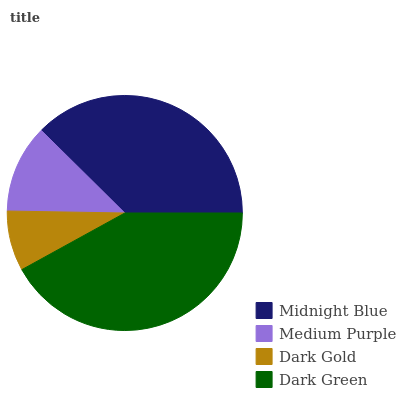Is Dark Gold the minimum?
Answer yes or no. Yes. Is Dark Green the maximum?
Answer yes or no. Yes. Is Medium Purple the minimum?
Answer yes or no. No. Is Medium Purple the maximum?
Answer yes or no. No. Is Midnight Blue greater than Medium Purple?
Answer yes or no. Yes. Is Medium Purple less than Midnight Blue?
Answer yes or no. Yes. Is Medium Purple greater than Midnight Blue?
Answer yes or no. No. Is Midnight Blue less than Medium Purple?
Answer yes or no. No. Is Midnight Blue the high median?
Answer yes or no. Yes. Is Medium Purple the low median?
Answer yes or no. Yes. Is Dark Green the high median?
Answer yes or no. No. Is Midnight Blue the low median?
Answer yes or no. No. 